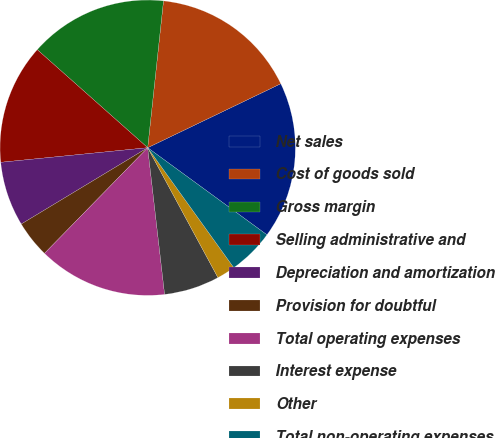Convert chart to OTSL. <chart><loc_0><loc_0><loc_500><loc_500><pie_chart><fcel>Net sales<fcel>Cost of goods sold<fcel>Gross margin<fcel>Selling administrative and<fcel>Depreciation and amortization<fcel>Provision for doubtful<fcel>Total operating expenses<fcel>Interest expense<fcel>Other<fcel>Total non-operating expenses<nl><fcel>17.17%<fcel>16.16%<fcel>15.15%<fcel>13.13%<fcel>7.07%<fcel>4.04%<fcel>14.14%<fcel>6.06%<fcel>2.02%<fcel>5.05%<nl></chart> 